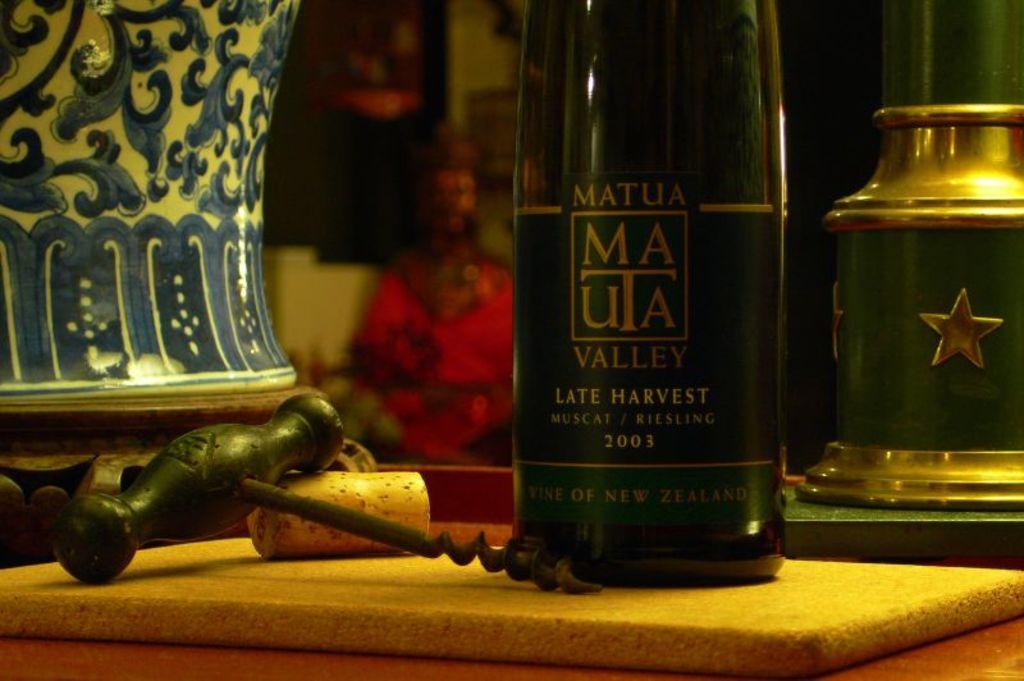What is the production year of this bottle of wine?
Keep it short and to the point. 2003. What brand of wine is this?
Provide a short and direct response. Matua. 